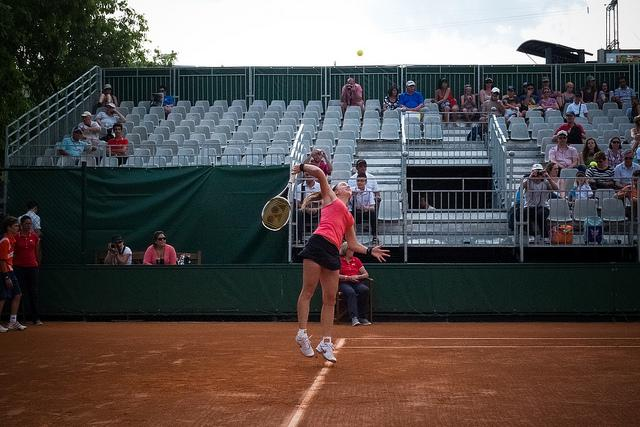What type of shot is the woman about to hit? serve 